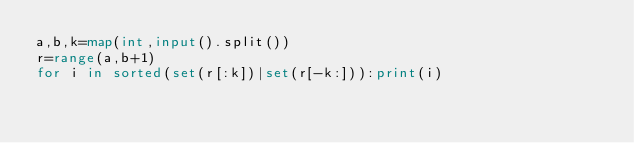<code> <loc_0><loc_0><loc_500><loc_500><_Python_>a,b,k=map(int,input().split())
r=range(a,b+1)
for i in sorted(set(r[:k])|set(r[-k:])):print(i)</code> 